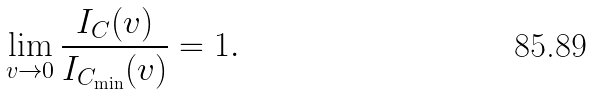<formula> <loc_0><loc_0><loc_500><loc_500>\lim _ { v \to 0 } \frac { I _ { C } ( v ) } { I _ { C _ { \min } } ( v ) } = 1 .</formula> 